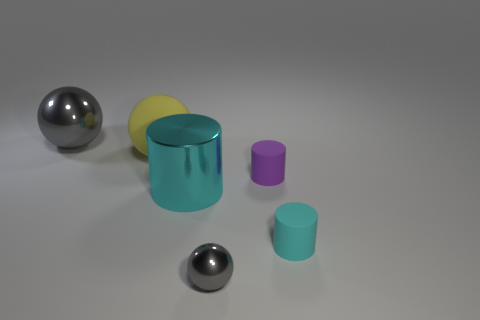Can you describe the lighting in this scene? The lighting of the scene appears to be diffused, with a soft shadow cast beneath each object, indicating an overhead light source with moderate intensity. The lack of harsh shadows or strong contrasts suggests a controlled lighting environment, typical of studio lighting used in photography or 3D renderings. 